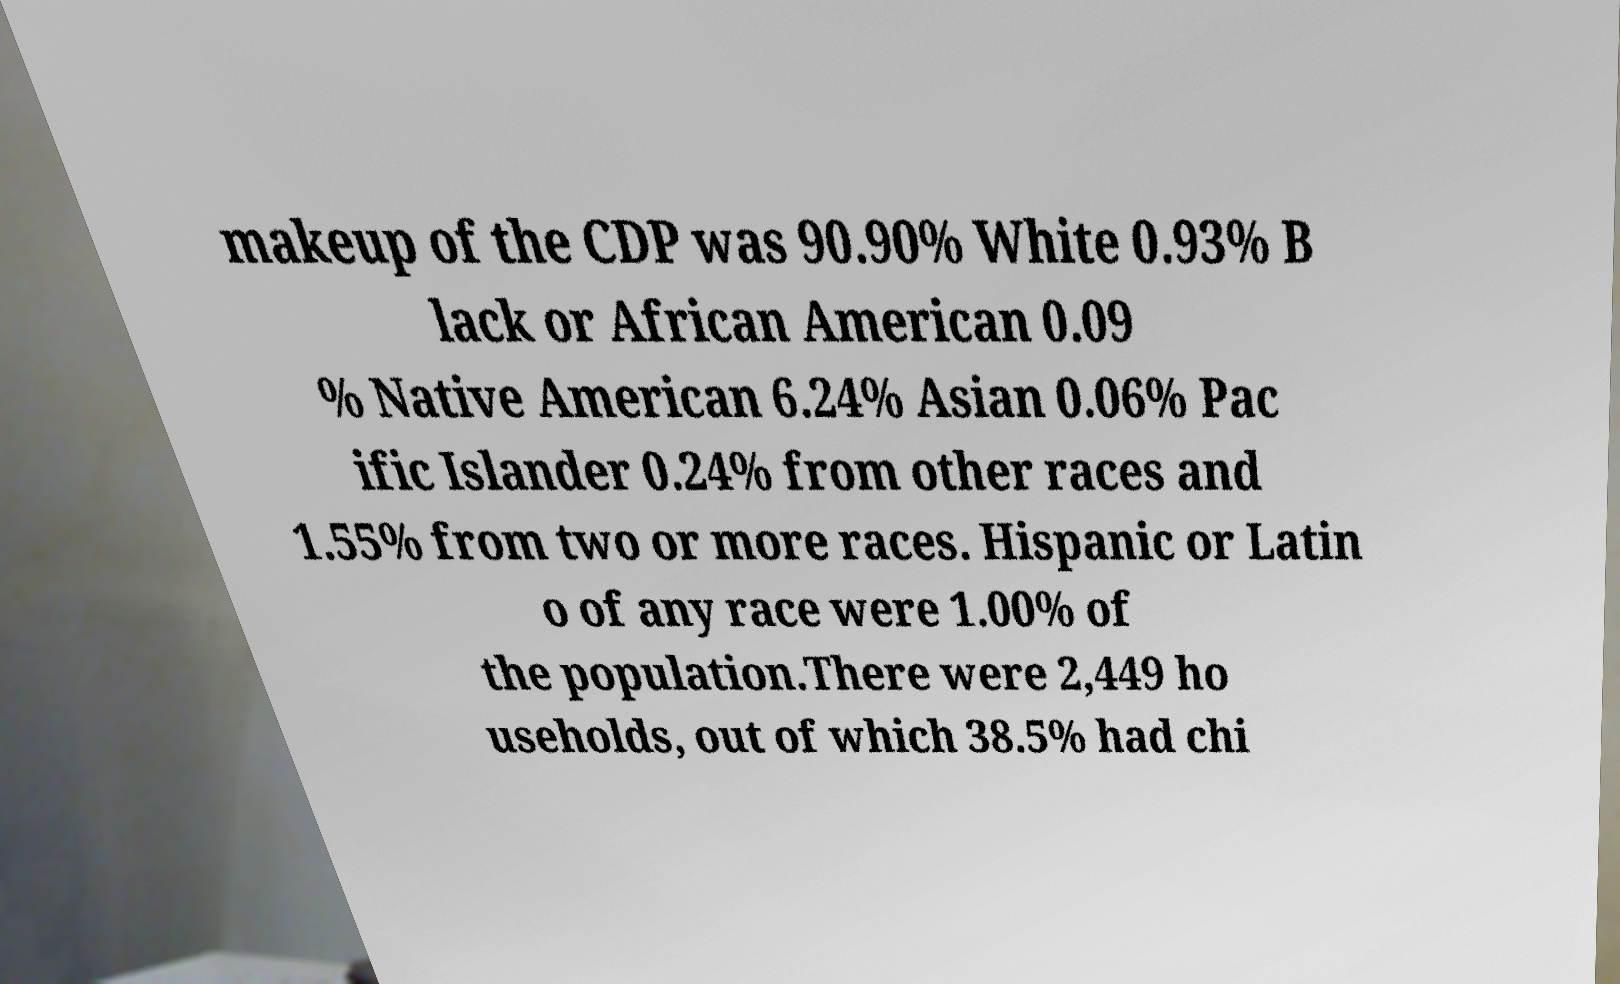There's text embedded in this image that I need extracted. Can you transcribe it verbatim? makeup of the CDP was 90.90% White 0.93% B lack or African American 0.09 % Native American 6.24% Asian 0.06% Pac ific Islander 0.24% from other races and 1.55% from two or more races. Hispanic or Latin o of any race were 1.00% of the population.There were 2,449 ho useholds, out of which 38.5% had chi 